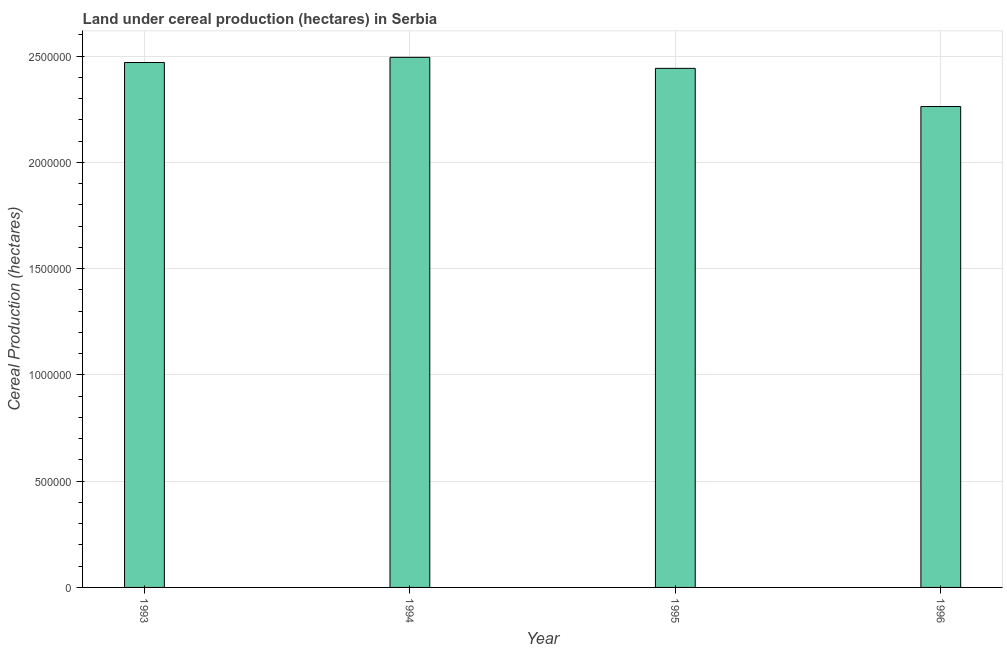What is the title of the graph?
Make the answer very short. Land under cereal production (hectares) in Serbia. What is the label or title of the Y-axis?
Provide a succinct answer. Cereal Production (hectares). What is the land under cereal production in 1996?
Your response must be concise. 2.26e+06. Across all years, what is the maximum land under cereal production?
Your answer should be very brief. 2.49e+06. Across all years, what is the minimum land under cereal production?
Ensure brevity in your answer.  2.26e+06. What is the sum of the land under cereal production?
Your response must be concise. 9.67e+06. What is the difference between the land under cereal production in 1995 and 1996?
Provide a short and direct response. 1.80e+05. What is the average land under cereal production per year?
Offer a very short reply. 2.42e+06. What is the median land under cereal production?
Your answer should be compact. 2.46e+06. In how many years, is the land under cereal production greater than 1200000 hectares?
Make the answer very short. 4. What is the ratio of the land under cereal production in 1994 to that in 1995?
Provide a succinct answer. 1.02. Is the land under cereal production in 1993 less than that in 1994?
Offer a terse response. Yes. Is the difference between the land under cereal production in 1995 and 1996 greater than the difference between any two years?
Offer a terse response. No. What is the difference between the highest and the second highest land under cereal production?
Provide a short and direct response. 2.43e+04. Is the sum of the land under cereal production in 1993 and 1995 greater than the maximum land under cereal production across all years?
Ensure brevity in your answer.  Yes. What is the difference between the highest and the lowest land under cereal production?
Your answer should be very brief. 2.32e+05. In how many years, is the land under cereal production greater than the average land under cereal production taken over all years?
Provide a succinct answer. 3. How many bars are there?
Make the answer very short. 4. Are all the bars in the graph horizontal?
Your response must be concise. No. What is the difference between two consecutive major ticks on the Y-axis?
Offer a very short reply. 5.00e+05. What is the Cereal Production (hectares) in 1993?
Offer a very short reply. 2.47e+06. What is the Cereal Production (hectares) in 1994?
Your answer should be compact. 2.49e+06. What is the Cereal Production (hectares) of 1995?
Make the answer very short. 2.44e+06. What is the Cereal Production (hectares) in 1996?
Your answer should be compact. 2.26e+06. What is the difference between the Cereal Production (hectares) in 1993 and 1994?
Give a very brief answer. -2.43e+04. What is the difference between the Cereal Production (hectares) in 1993 and 1995?
Your answer should be compact. 2.76e+04. What is the difference between the Cereal Production (hectares) in 1993 and 1996?
Provide a short and direct response. 2.07e+05. What is the difference between the Cereal Production (hectares) in 1994 and 1995?
Provide a short and direct response. 5.19e+04. What is the difference between the Cereal Production (hectares) in 1994 and 1996?
Your response must be concise. 2.32e+05. What is the difference between the Cereal Production (hectares) in 1995 and 1996?
Make the answer very short. 1.80e+05. What is the ratio of the Cereal Production (hectares) in 1993 to that in 1994?
Give a very brief answer. 0.99. What is the ratio of the Cereal Production (hectares) in 1993 to that in 1996?
Give a very brief answer. 1.09. What is the ratio of the Cereal Production (hectares) in 1994 to that in 1996?
Give a very brief answer. 1.1. What is the ratio of the Cereal Production (hectares) in 1995 to that in 1996?
Your answer should be compact. 1.08. 